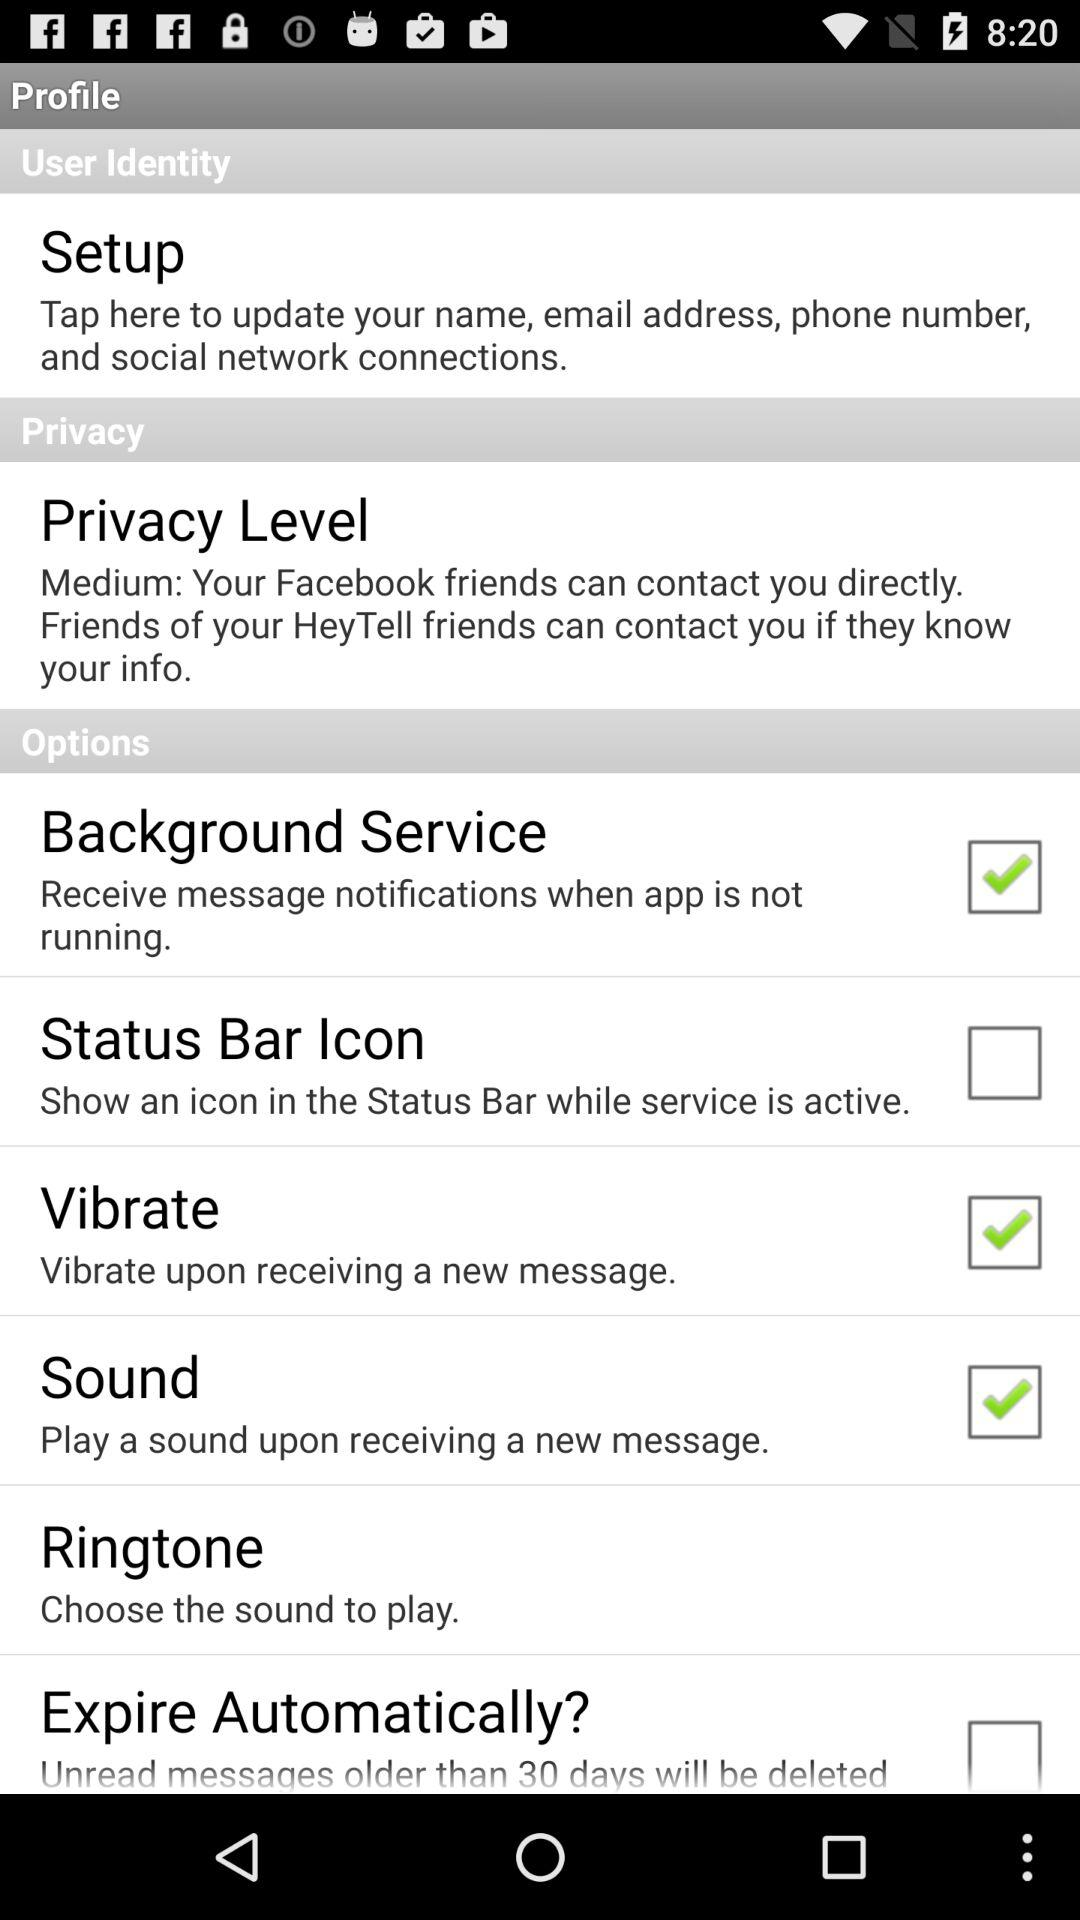What is the status of the "Expire Automatically?" setting? The status is "off". 